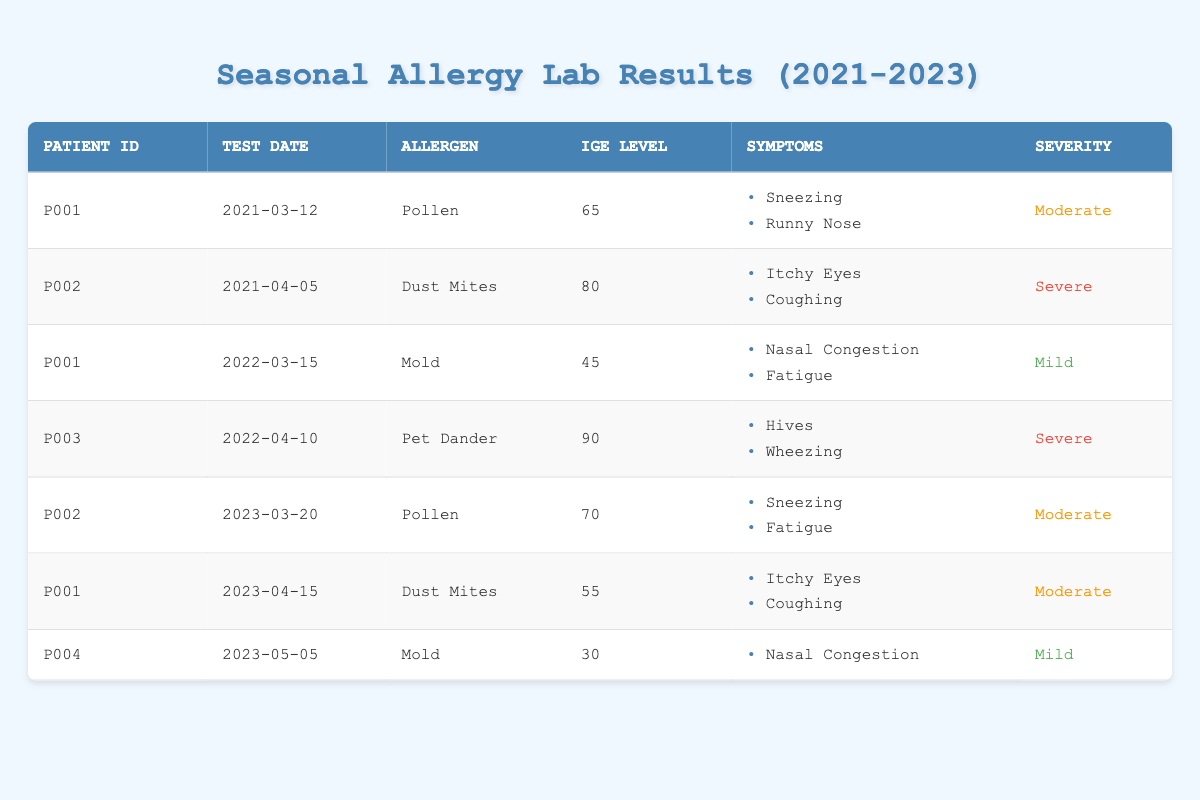What is the IgE level for patient P002 on April 5, 2021? In the table, locate the row with patient ID P002 and the test date April 5, 2021. The IgE level listed for this record is 80.
Answer: 80 How many patients exhibited severe symptoms in 2022? Reviewing the table, I can see two records for 2022: P002 with severe symptoms from Dust Mites and P003 with severe symptoms from Pet Dander. Therefore, there are two patients with severe symptoms in 2022.
Answer: 2 What is the average IgE level for patient P001 over the three years? P001 has three IgE levels recorded: 65 (Pollen), 45 (Mold), and 55 (Dust Mites). The average is calculated by summing the levels (65 + 45 + 55) = 165 and dividing by 3, resulting in 165/3 = 55.
Answer: 55 Did patient P004 have any severe symptoms during the tested period? Patient P004 had a single entry with an IgE level of 30 for Mold and was reported with mild symptoms (Nasal Congestion). Since mild does not correlate with severe, the answer is no.
Answer: No Which allergen caused the highest IgE level in the recorded data? By examining the IgE levels in the table, the highest recorded value is for patient P003 with an IgE level of 90 for Pet Dander.
Answer: Pet Dander Which patient had moderate symptoms during their last recorded test? The last test date in the data is May 5, 2023, for patient P004, who has mild symptoms. However, the last moderate symptoms were recorded for patient P002 on March 20, 2023. Therefore, P002 had moderate symptoms in their last recorded test.
Answer: P002 How many different allergens were tested for patient P001? Patient P001 was tested for two allergens: Pollen in 2021 and Mold in 2022, and Dust Mites in 2023. This sums up to three different allergens.
Answer: 3 What severity level was associated with the IgE level of 30? The table shows that the IgE level of 30 corresponds to mild symptoms for patient P004 on May 5, 2023.
Answer: Mild What percentage of total test results were classified as severe? There are 7 total test results in the table, with 3 classified as severe (P002 in 2021, P003 in 2022, and P002 again in 2023). The percentage is calculated as (3/7) * 100 = approximately 42.86%.
Answer: 42.86% 